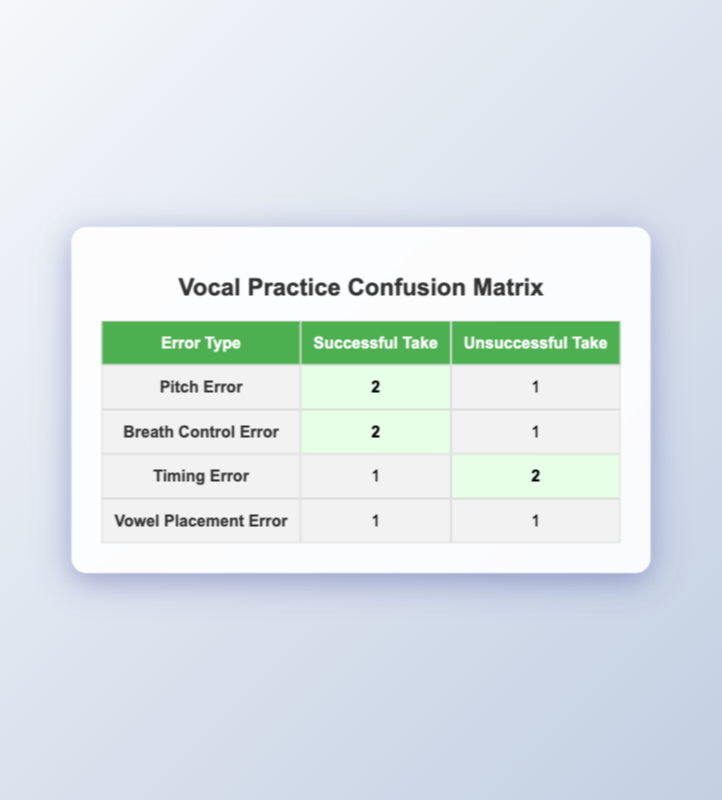What is the number of successful takes for Pitch Error? In the table, under the Pitch Error row, the highlighted cell for Successful Take shows the number 2. This indicates that there were two successful takes for Pitch Error.
Answer: 2 How many unsuccessful takes were recorded for Timing Errors? Under the Timing Error row, the cell for Unsuccessful Take shows the number 2. This reflects that there were two unsuccessful takes for Timing Errors.
Answer: 2 What is the total count of successful takes across all error types? Adding the successful tallies from each row: Pitch Error (2) + Breath Control Error (2) + Timing Error (1) + Vowel Placement Error (1) equals a total of 6 successful takes.
Answer: 6 Is there at least one session recorded with a successful take for Vowel Placement Error? In the Vowel Placement Error row, the successful take count is listed as 1. This confirms that there was at least one successful take for Vowel Placement Error.
Answer: Yes Which error type had the highest number of successful takes? By evaluating the successful take counts, both Pitch Error and Breath Control Error have the highest counts at 2 each, making them tied for the highest number.
Answer: Pitch Error and Breath Control Error How many total errors were recorded across all successful takes? The successful take counts are: Pitch Error (2) + Breath Control Error (2) + Timing Error (1) + Vowel Placement Error (1) totals to 6 successful takes. There were no errors recorded for successful takes, so the total remains 6.
Answer: 6 Did every error type have successful takes? By looking at each error type, Timing Error had one successful take but also two unsuccessful takes, and Vowel Placement Error had one successful take. Therefore, not every error type had a successful take—only the ones with a count greater than zero did.
Answer: No What is the ratio of successful takes to unsuccessful takes for Breath Control Error? The successful take count for Breath Control Error is 2, and the unsuccessful count is 1. The ratio can be calculated as 2 (successful) to 1 (unsuccessful), which simplifies to 2:1.
Answer: 2:1 